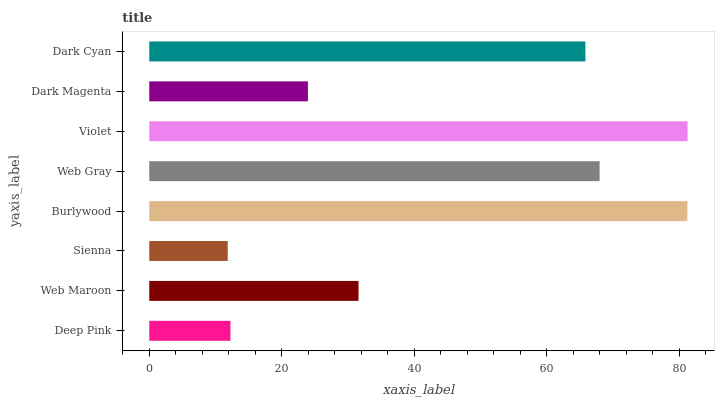Is Sienna the minimum?
Answer yes or no. Yes. Is Violet the maximum?
Answer yes or no. Yes. Is Web Maroon the minimum?
Answer yes or no. No. Is Web Maroon the maximum?
Answer yes or no. No. Is Web Maroon greater than Deep Pink?
Answer yes or no. Yes. Is Deep Pink less than Web Maroon?
Answer yes or no. Yes. Is Deep Pink greater than Web Maroon?
Answer yes or no. No. Is Web Maroon less than Deep Pink?
Answer yes or no. No. Is Dark Cyan the high median?
Answer yes or no. Yes. Is Web Maroon the low median?
Answer yes or no. Yes. Is Burlywood the high median?
Answer yes or no. No. Is Burlywood the low median?
Answer yes or no. No. 